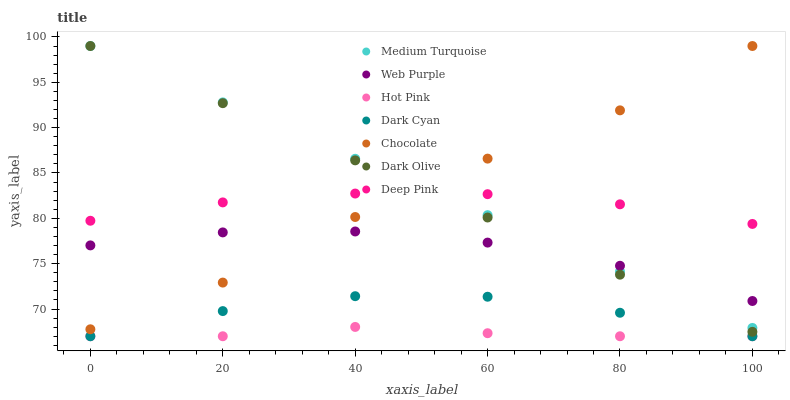Does Hot Pink have the minimum area under the curve?
Answer yes or no. Yes. Does Medium Turquoise have the maximum area under the curve?
Answer yes or no. Yes. Does Chocolate have the minimum area under the curve?
Answer yes or no. No. Does Chocolate have the maximum area under the curve?
Answer yes or no. No. Is Dark Olive the smoothest?
Answer yes or no. Yes. Is Chocolate the roughest?
Answer yes or no. Yes. Is Hot Pink the smoothest?
Answer yes or no. No. Is Hot Pink the roughest?
Answer yes or no. No. Does Hot Pink have the lowest value?
Answer yes or no. Yes. Does Chocolate have the lowest value?
Answer yes or no. No. Does Medium Turquoise have the highest value?
Answer yes or no. Yes. Does Hot Pink have the highest value?
Answer yes or no. No. Is Dark Cyan less than Dark Olive?
Answer yes or no. Yes. Is Web Purple greater than Hot Pink?
Answer yes or no. Yes. Does Chocolate intersect Dark Olive?
Answer yes or no. Yes. Is Chocolate less than Dark Olive?
Answer yes or no. No. Is Chocolate greater than Dark Olive?
Answer yes or no. No. Does Dark Cyan intersect Dark Olive?
Answer yes or no. No. 